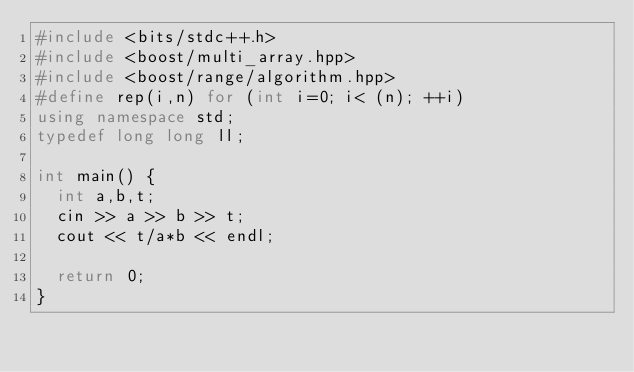<code> <loc_0><loc_0><loc_500><loc_500><_C++_>#include <bits/stdc++.h>
#include <boost/multi_array.hpp>
#include <boost/range/algorithm.hpp>
#define rep(i,n) for (int i=0; i< (n); ++i)
using namespace std;
typedef long long ll;

int main() {
  int a,b,t;
  cin >> a >> b >> t;
  cout << t/a*b << endl;

  return 0;
}
</code> 